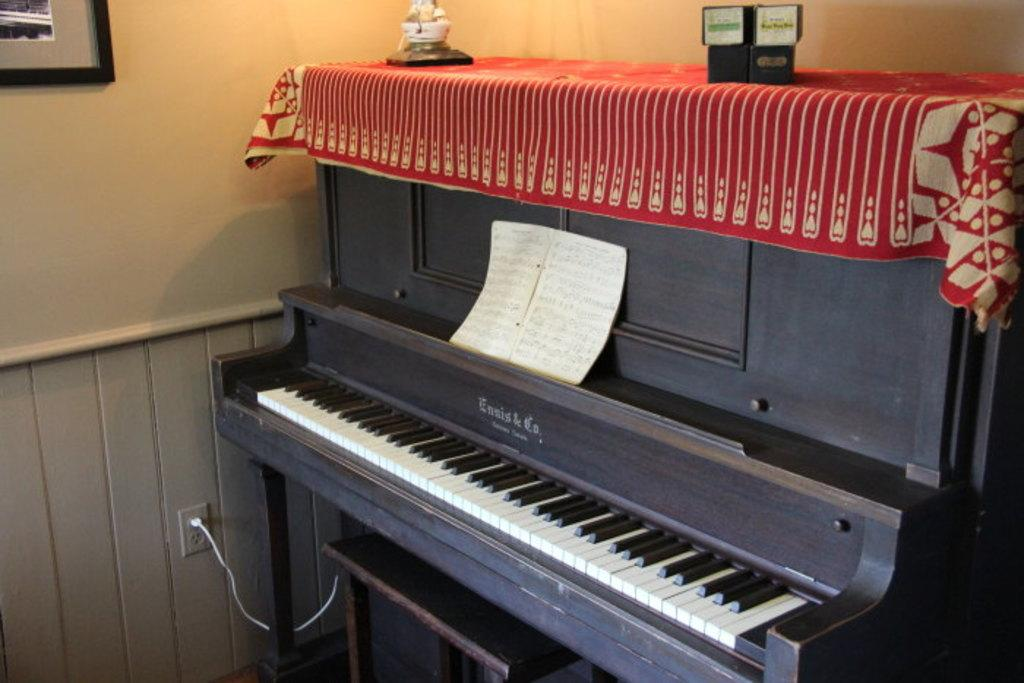What musical instrument is present in the image? There is a piano in the image. What is covering the piano? There is a cloth on the piano. What else can be seen in the image besides the piano? There is a book in the image. What is hanging on the wall in the image? There is a photograph on the wall. What type of distribution system is depicted in the image? There is no distribution system present in the image; it features a piano, cloth, book, and photograph. What type of cannon is visible in the image? There is no cannon present in the image. 